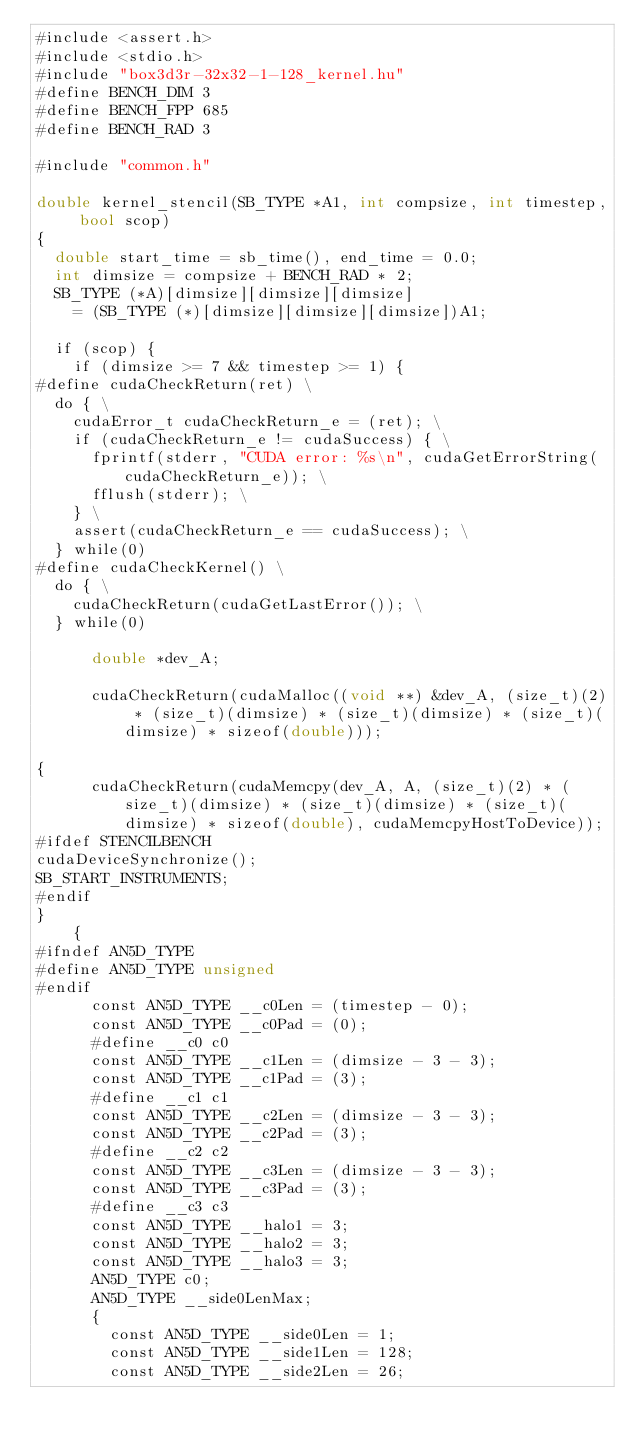<code> <loc_0><loc_0><loc_500><loc_500><_Cuda_>#include <assert.h>
#include <stdio.h>
#include "box3d3r-32x32-1-128_kernel.hu"
#define BENCH_DIM 3
#define BENCH_FPP 685
#define BENCH_RAD 3

#include "common.h"

double kernel_stencil(SB_TYPE *A1, int compsize, int timestep, bool scop)
{
  double start_time = sb_time(), end_time = 0.0;
  int dimsize = compsize + BENCH_RAD * 2;
  SB_TYPE (*A)[dimsize][dimsize][dimsize]
    = (SB_TYPE (*)[dimsize][dimsize][dimsize])A1;

  if (scop) {
    if (dimsize >= 7 && timestep >= 1) {
#define cudaCheckReturn(ret) \
  do { \
    cudaError_t cudaCheckReturn_e = (ret); \
    if (cudaCheckReturn_e != cudaSuccess) { \
      fprintf(stderr, "CUDA error: %s\n", cudaGetErrorString(cudaCheckReturn_e)); \
      fflush(stderr); \
    } \
    assert(cudaCheckReturn_e == cudaSuccess); \
  } while(0)
#define cudaCheckKernel() \
  do { \
    cudaCheckReturn(cudaGetLastError()); \
  } while(0)

      double *dev_A;
      
      cudaCheckReturn(cudaMalloc((void **) &dev_A, (size_t)(2) * (size_t)(dimsize) * (size_t)(dimsize) * (size_t)(dimsize) * sizeof(double)));
      
{
      cudaCheckReturn(cudaMemcpy(dev_A, A, (size_t)(2) * (size_t)(dimsize) * (size_t)(dimsize) * (size_t)(dimsize) * sizeof(double), cudaMemcpyHostToDevice));
#ifdef STENCILBENCH
cudaDeviceSynchronize();
SB_START_INSTRUMENTS;
#endif
}
    {
#ifndef AN5D_TYPE
#define AN5D_TYPE unsigned
#endif
      const AN5D_TYPE __c0Len = (timestep - 0);
      const AN5D_TYPE __c0Pad = (0);
      #define __c0 c0
      const AN5D_TYPE __c1Len = (dimsize - 3 - 3);
      const AN5D_TYPE __c1Pad = (3);
      #define __c1 c1
      const AN5D_TYPE __c2Len = (dimsize - 3 - 3);
      const AN5D_TYPE __c2Pad = (3);
      #define __c2 c2
      const AN5D_TYPE __c3Len = (dimsize - 3 - 3);
      const AN5D_TYPE __c3Pad = (3);
      #define __c3 c3
      const AN5D_TYPE __halo1 = 3;
      const AN5D_TYPE __halo2 = 3;
      const AN5D_TYPE __halo3 = 3;
      AN5D_TYPE c0;
      AN5D_TYPE __side0LenMax;
      {
        const AN5D_TYPE __side0Len = 1;
        const AN5D_TYPE __side1Len = 128;
        const AN5D_TYPE __side2Len = 26;</code> 